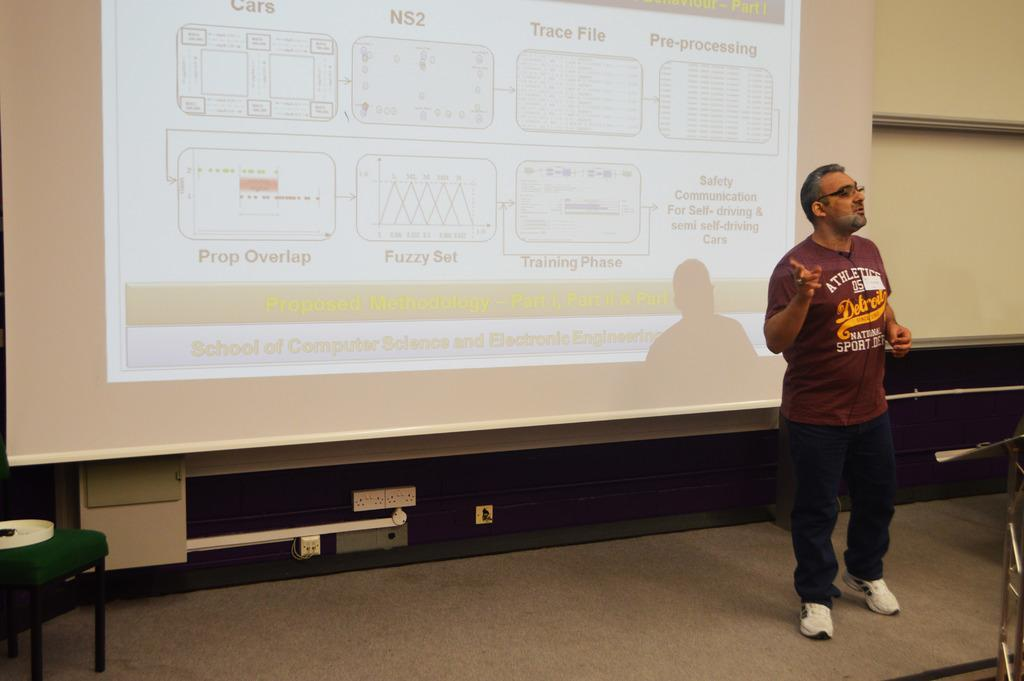Provide a one-sentence caption for the provided image. A man doing a presentation on computer science and electronic engineering. 